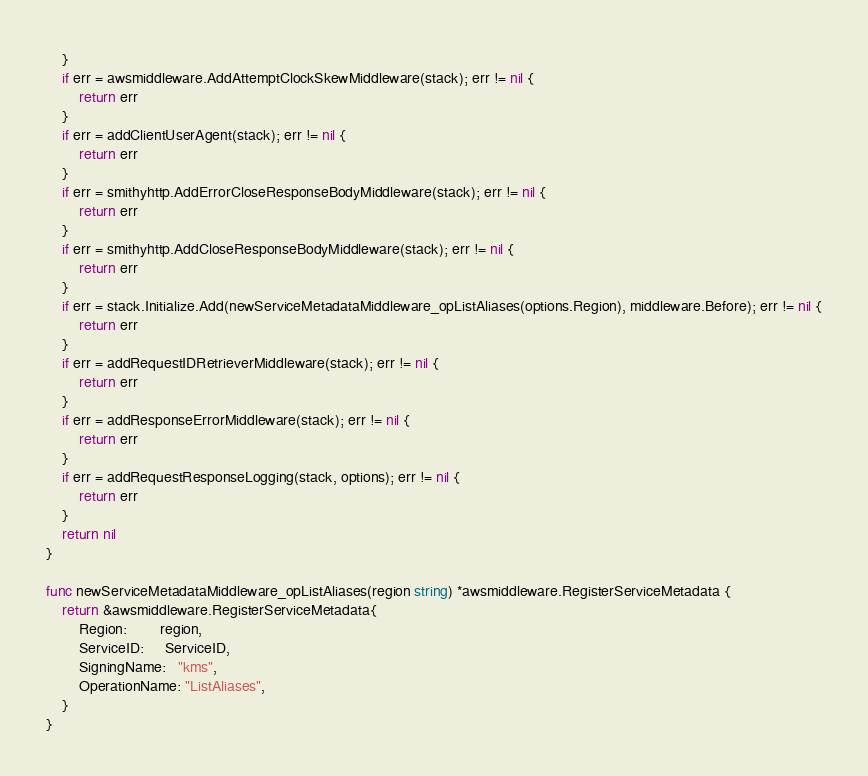Convert code to text. <code><loc_0><loc_0><loc_500><loc_500><_Go_>	}
	if err = awsmiddleware.AddAttemptClockSkewMiddleware(stack); err != nil {
		return err
	}
	if err = addClientUserAgent(stack); err != nil {
		return err
	}
	if err = smithyhttp.AddErrorCloseResponseBodyMiddleware(stack); err != nil {
		return err
	}
	if err = smithyhttp.AddCloseResponseBodyMiddleware(stack); err != nil {
		return err
	}
	if err = stack.Initialize.Add(newServiceMetadataMiddleware_opListAliases(options.Region), middleware.Before); err != nil {
		return err
	}
	if err = addRequestIDRetrieverMiddleware(stack); err != nil {
		return err
	}
	if err = addResponseErrorMiddleware(stack); err != nil {
		return err
	}
	if err = addRequestResponseLogging(stack, options); err != nil {
		return err
	}
	return nil
}

func newServiceMetadataMiddleware_opListAliases(region string) *awsmiddleware.RegisterServiceMetadata {
	return &awsmiddleware.RegisterServiceMetadata{
		Region:        region,
		ServiceID:     ServiceID,
		SigningName:   "kms",
		OperationName: "ListAliases",
	}
}
</code> 